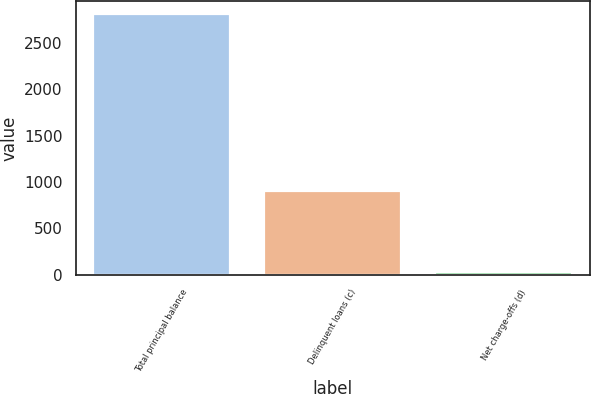Convert chart. <chart><loc_0><loc_0><loc_500><loc_500><bar_chart><fcel>Total principal balance<fcel>Delinquent loans (c)<fcel>Net charge-offs (d)<nl><fcel>2806<fcel>904<fcel>28<nl></chart> 